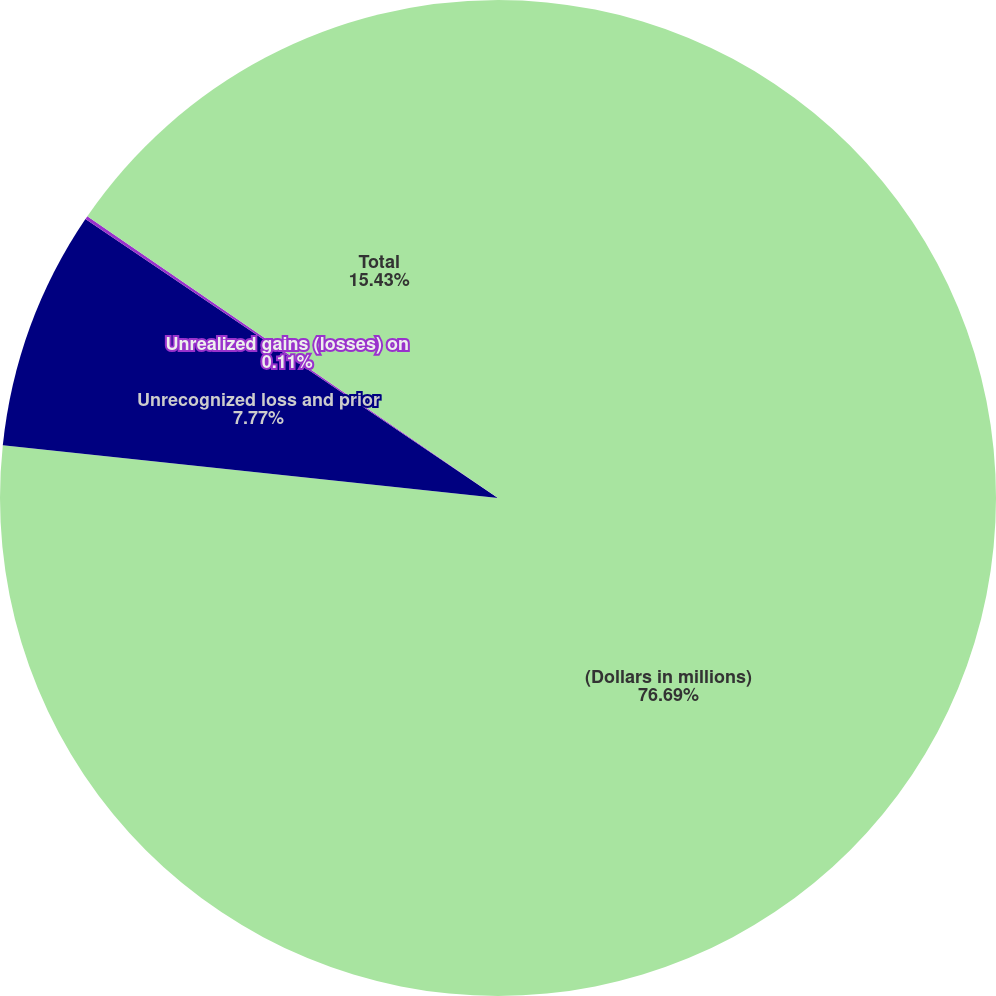<chart> <loc_0><loc_0><loc_500><loc_500><pie_chart><fcel>(Dollars in millions)<fcel>Unrecognized loss and prior<fcel>Unrealized gains (losses) on<fcel>Total<nl><fcel>76.69%<fcel>7.77%<fcel>0.11%<fcel>15.43%<nl></chart> 